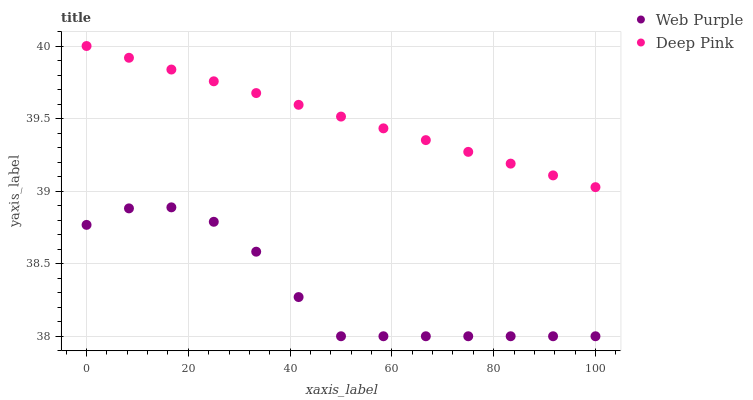Does Web Purple have the minimum area under the curve?
Answer yes or no. Yes. Does Deep Pink have the maximum area under the curve?
Answer yes or no. Yes. Does Deep Pink have the minimum area under the curve?
Answer yes or no. No. Is Deep Pink the smoothest?
Answer yes or no. Yes. Is Web Purple the roughest?
Answer yes or no. Yes. Is Deep Pink the roughest?
Answer yes or no. No. Does Web Purple have the lowest value?
Answer yes or no. Yes. Does Deep Pink have the lowest value?
Answer yes or no. No. Does Deep Pink have the highest value?
Answer yes or no. Yes. Is Web Purple less than Deep Pink?
Answer yes or no. Yes. Is Deep Pink greater than Web Purple?
Answer yes or no. Yes. Does Web Purple intersect Deep Pink?
Answer yes or no. No. 